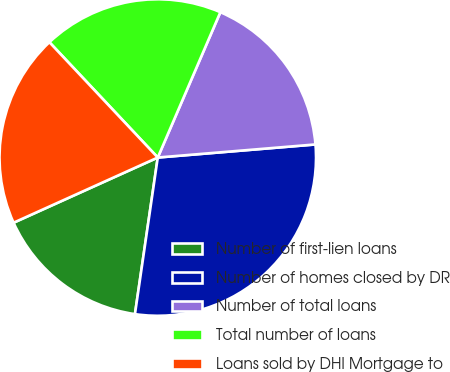Convert chart to OTSL. <chart><loc_0><loc_0><loc_500><loc_500><pie_chart><fcel>Number of first-lien loans<fcel>Number of homes closed by DR<fcel>Number of total loans<fcel>Total number of loans<fcel>Loans sold by DHI Mortgage to<nl><fcel>15.94%<fcel>28.62%<fcel>17.21%<fcel>18.48%<fcel>19.75%<nl></chart> 